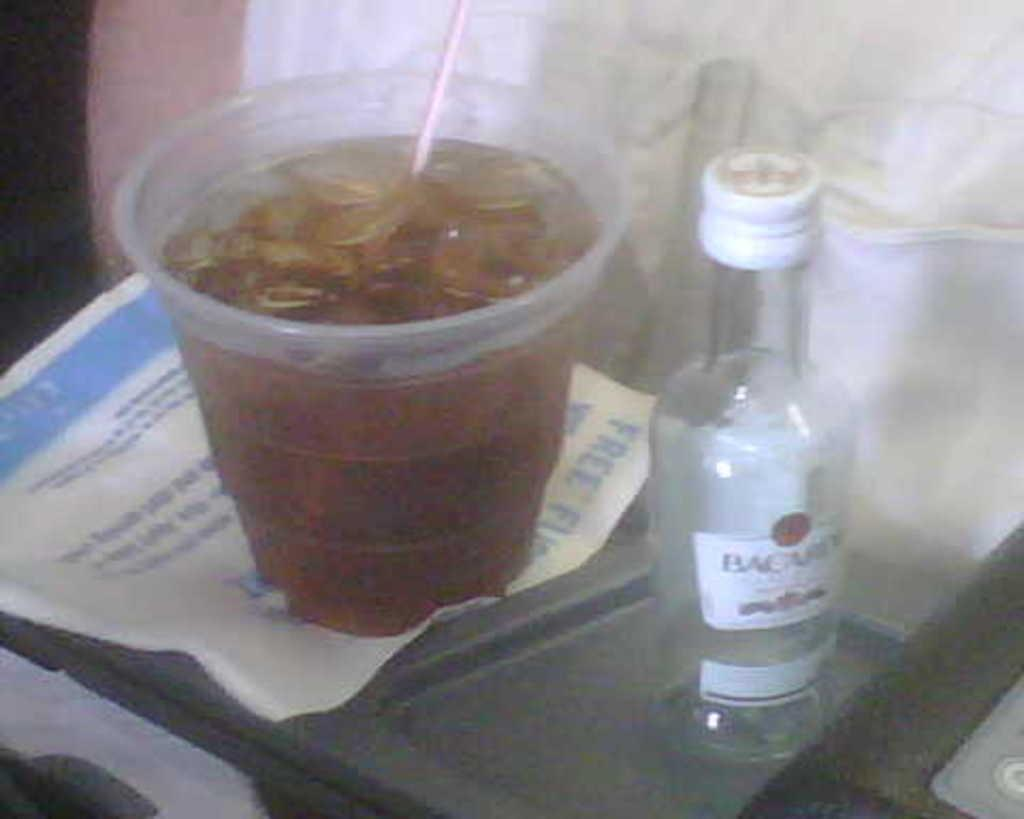<image>
Offer a succinct explanation of the picture presented. a small empty bottle of Bacardi next to a cup with brown liquid 